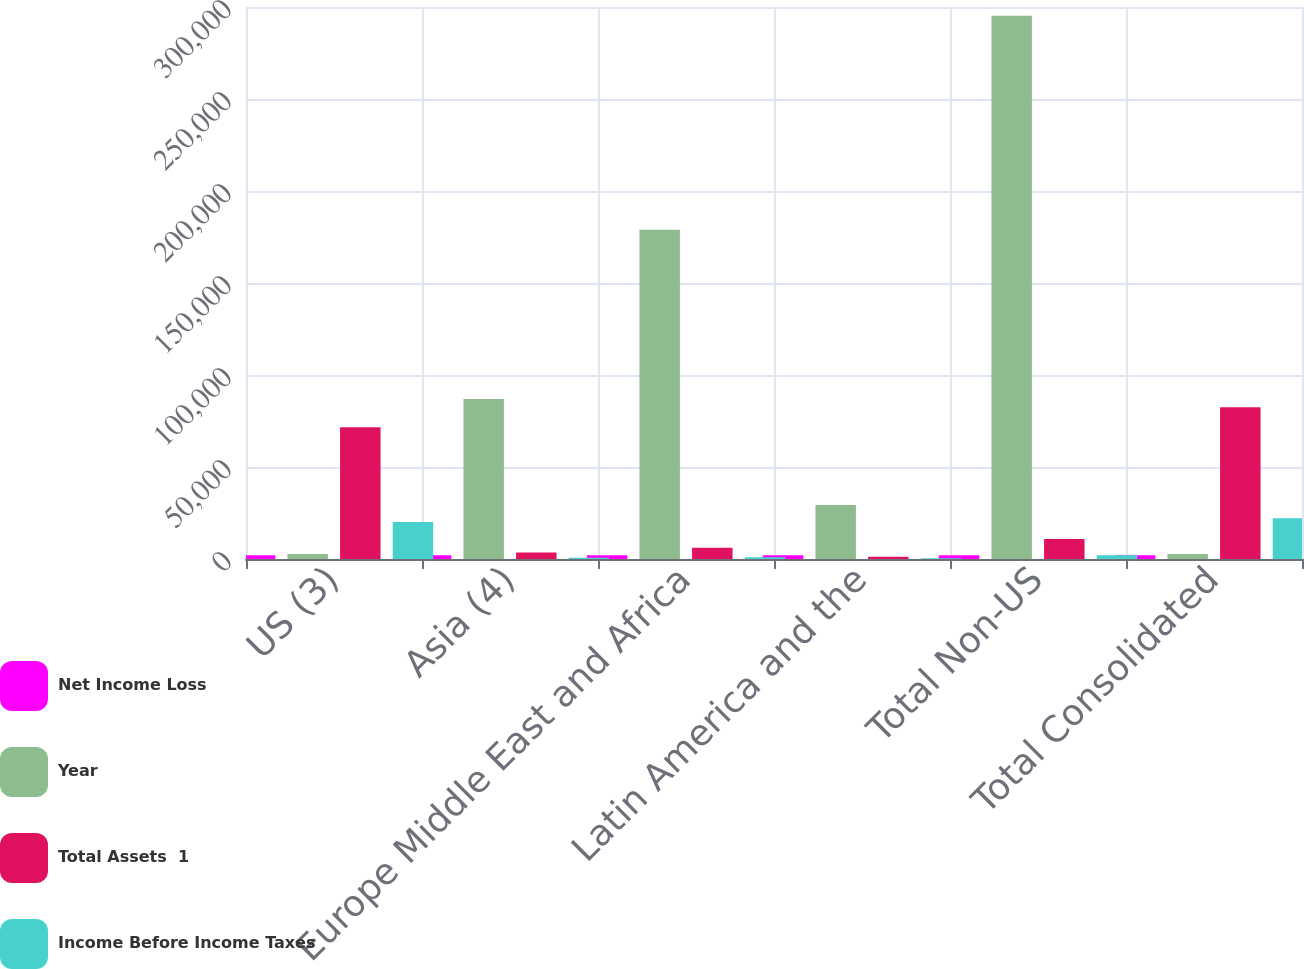Convert chart. <chart><loc_0><loc_0><loc_500><loc_500><stacked_bar_chart><ecel><fcel>US (3)<fcel>Asia (4)<fcel>Europe Middle East and Africa<fcel>Latin America and the<fcel>Total Non-US<fcel>Total Consolidated<nl><fcel>Net Income Loss<fcel>2015<fcel>2015<fcel>2015<fcel>2015<fcel>2015<fcel>2015<nl><fcel>Year<fcel>2769.5<fcel>86994<fcel>178899<fcel>29295<fcel>295188<fcel>2769.5<nl><fcel>Total Assets  1<fcel>71659<fcel>3524<fcel>6081<fcel>1243<fcel>10848<fcel>82507<nl><fcel>Income Before Income Taxes<fcel>20148<fcel>726<fcel>938<fcel>342<fcel>2006<fcel>22154<nl></chart> 